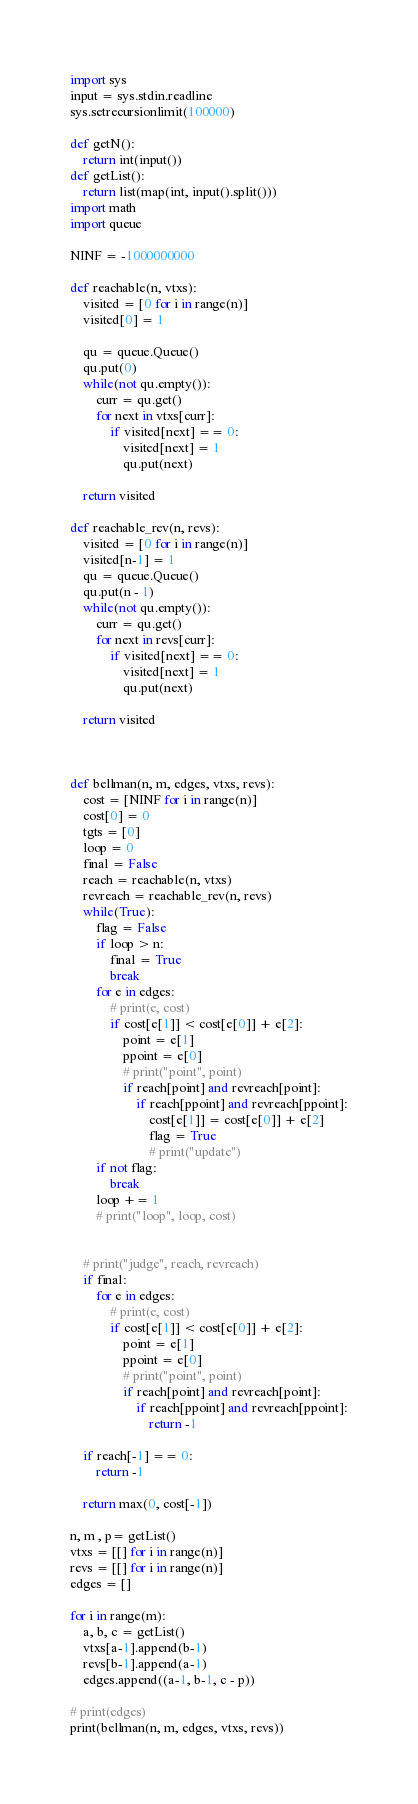Convert code to text. <code><loc_0><loc_0><loc_500><loc_500><_Python_>import sys
input = sys.stdin.readline
sys.setrecursionlimit(100000)

def getN():
    return int(input())
def getList():
    return list(map(int, input().split()))
import math
import queue

NINF = -1000000000

def reachable(n, vtxs):
    visited = [0 for i in range(n)]
    visited[0] = 1

    qu = queue.Queue()
    qu.put(0)
    while(not qu.empty()):
        curr = qu.get()
        for next in vtxs[curr]:
            if visited[next] == 0:
                visited[next] = 1
                qu.put(next)

    return visited

def reachable_rev(n, revs):
    visited = [0 for i in range(n)]
    visited[n-1] = 1
    qu = queue.Queue()
    qu.put(n - 1)
    while(not qu.empty()):
        curr = qu.get()
        for next in revs[curr]:
            if visited[next] == 0:
                visited[next] = 1
                qu.put(next)

    return visited



def bellman(n, m, edges, vtxs, revs):
    cost = [NINF for i in range(n)]
    cost[0] = 0
    tgts = [0]
    loop = 0
    final = False
    reach = reachable(n, vtxs)
    revreach = reachable_rev(n, revs)
    while(True):
        flag = False
        if loop > n:
            final = True
            break
        for e in edges:
            # print(e, cost)
            if cost[e[1]] < cost[e[0]] + e[2]:
                point = e[1]
                ppoint = e[0]
                # print("point", point)
                if reach[point] and revreach[point]:
                    if reach[ppoint] and revreach[ppoint]:
                        cost[e[1]] = cost[e[0]] + e[2]
                        flag = True
                        # print("update")
        if not flag:
            break
        loop += 1
        # print("loop", loop, cost)


    # print("judge", reach, revreach)
    if final:
        for e in edges:
            # print(e, cost)
            if cost[e[1]] < cost[e[0]] + e[2]:
                point = e[1]
                ppoint = e[0]
                # print("point", point)
                if reach[point] and revreach[point]:
                    if reach[ppoint] and revreach[ppoint]:
                        return -1

    if reach[-1] == 0:
        return -1

    return max(0, cost[-1])

n, m , p= getList()
vtxs = [[] for i in range(n)]
revs = [[] for i in range(n)]
edges = []

for i in range(m):
    a, b, c = getList()
    vtxs[a-1].append(b-1)
    revs[b-1].append(a-1)
    edges.append((a-1, b-1, c - p))

# print(edges)
print(bellman(n, m, edges, vtxs, revs))

</code> 